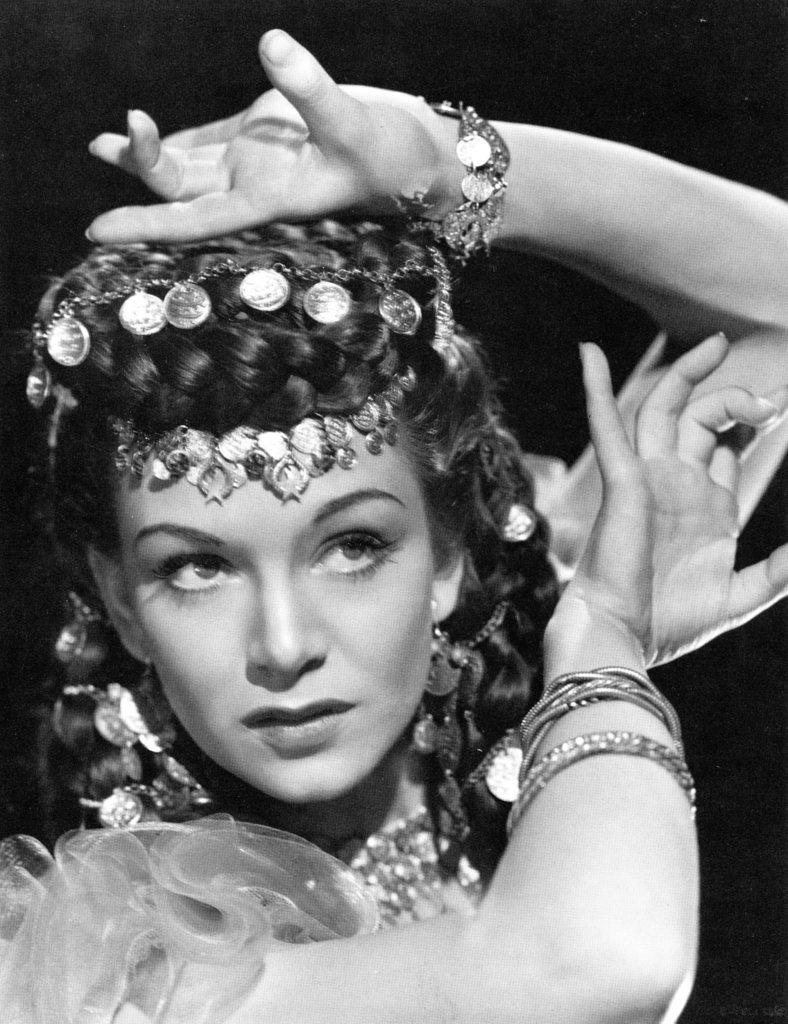Who is present in the image? There is a woman in the image. What can be observed about the background of the image? The background of the image is dark. What type of tin can be seen in the image? There is no tin present in the image. What time of day is depicted in the image? The provided facts do not give any information about the time of day, so it cannot be determined from the image. 